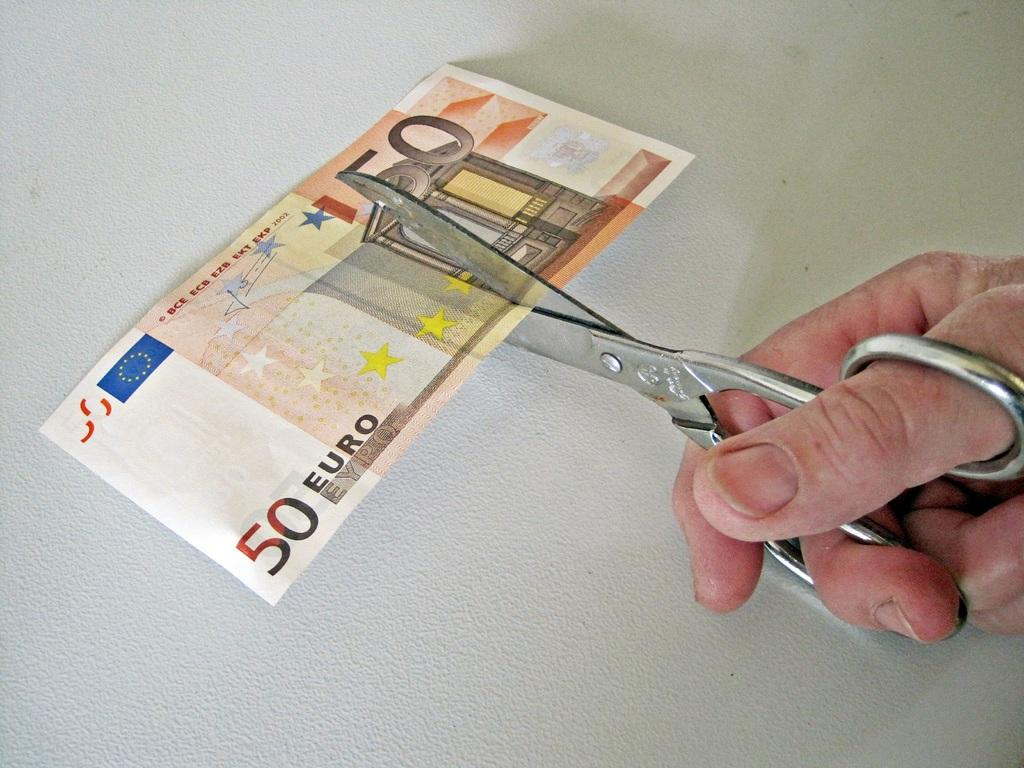Who is present in the image? There is a person in the image. What is the person holding in the image? The person is holding scissors. What is the person doing with the scissors? The person is cutting a currency note. What is the color of the surface in the image? The surface in the image is white. Where is the son sitting in the image? There is no son present in the image, nor are there any chairs or other seating depicted. 